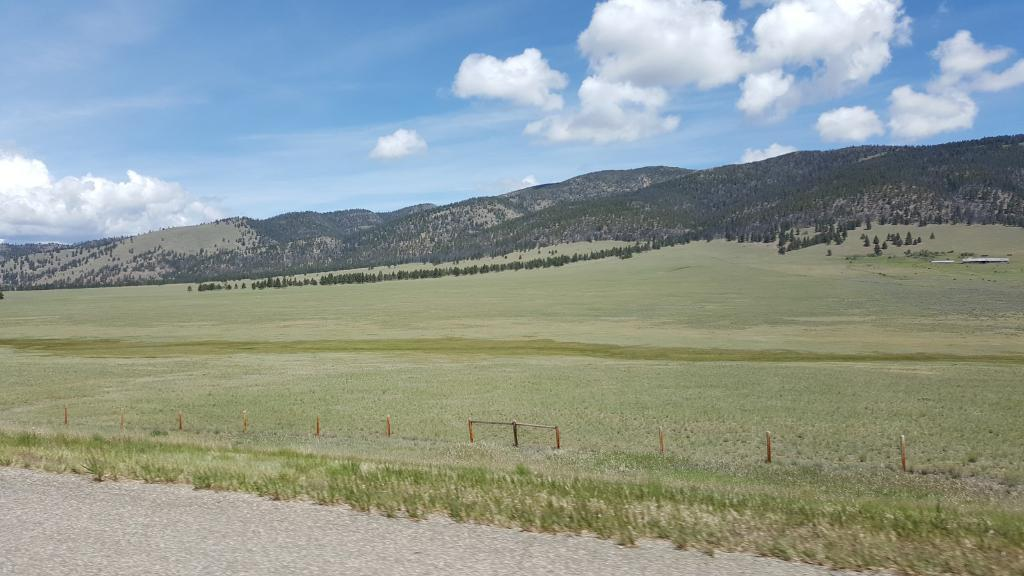What type of landscape is depicted in the image? The image features hills and trees, indicating a natural landscape. What type of vegetation can be seen in the image? There are trees and grass visible in the image. What is the color and condition of the sky in the image? The sky is blue and cloudy in the image. How many blades of grass can be seen in the image? It is not possible to count individual blades of grass in the image, as they are depicted as a collective mass of grass. Are there any ducks visible in the image? There are no ducks present in the image; it features hills, trees, grass, and a blue, cloudy sky. 